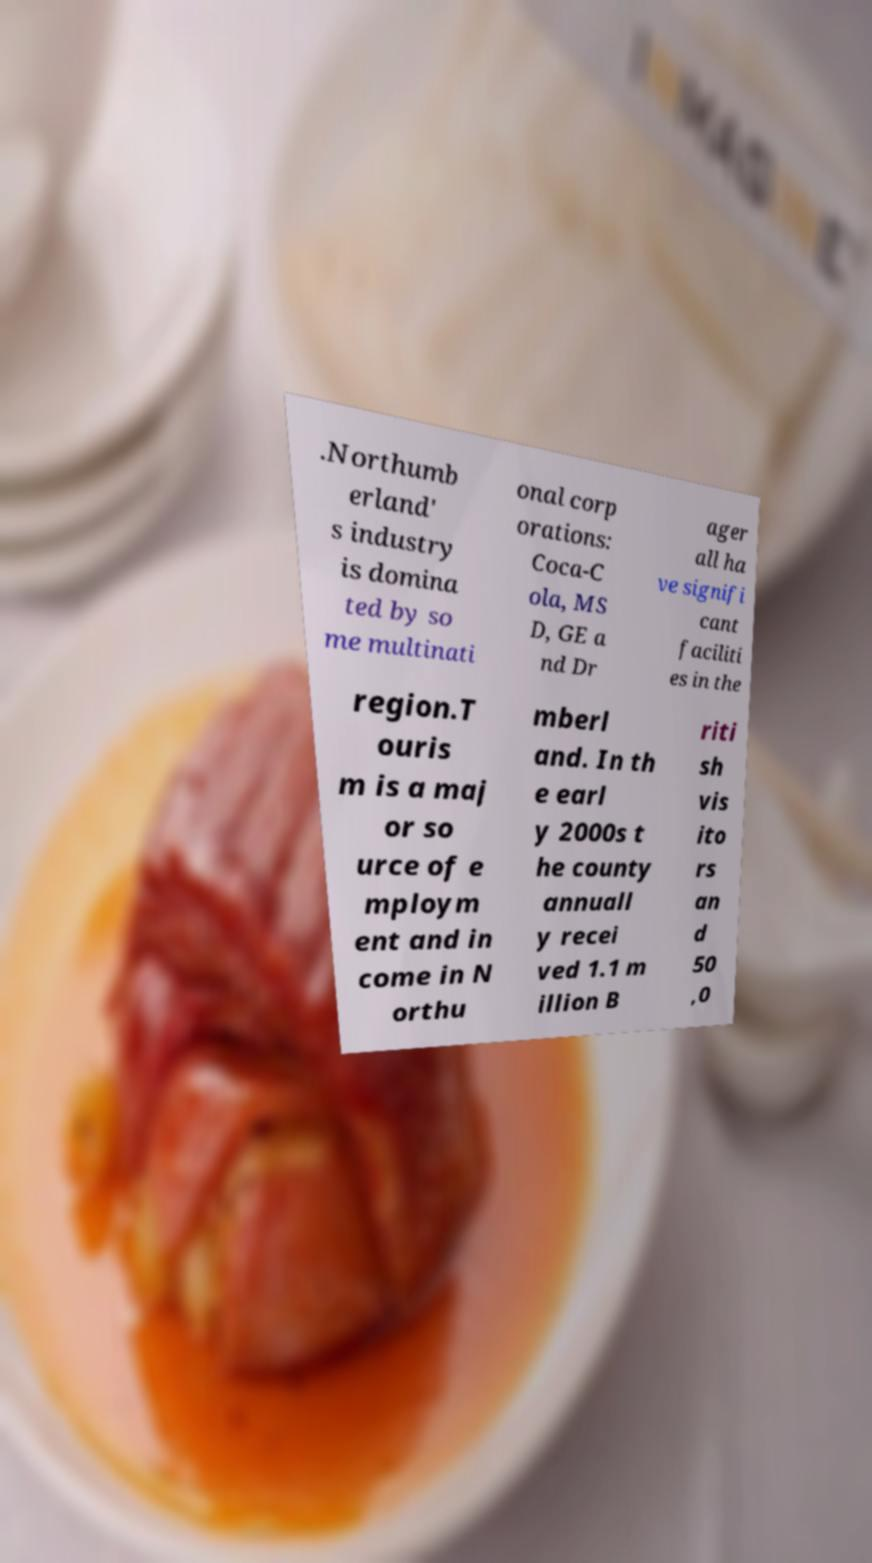What messages or text are displayed in this image? I need them in a readable, typed format. .Northumb erland' s industry is domina ted by so me multinati onal corp orations: Coca-C ola, MS D, GE a nd Dr ager all ha ve signifi cant faciliti es in the region.T ouris m is a maj or so urce of e mploym ent and in come in N orthu mberl and. In th e earl y 2000s t he county annuall y recei ved 1.1 m illion B riti sh vis ito rs an d 50 ,0 